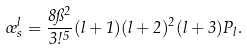Convert formula to latex. <formula><loc_0><loc_0><loc_500><loc_500>\sigma ^ { l } _ { s } = \frac { 8 \pi ^ { 2 } } { 3 \omega ^ { 5 } } ( l + 1 ) ( l + 2 ) ^ { 2 } ( l + 3 ) P _ { l } .</formula> 